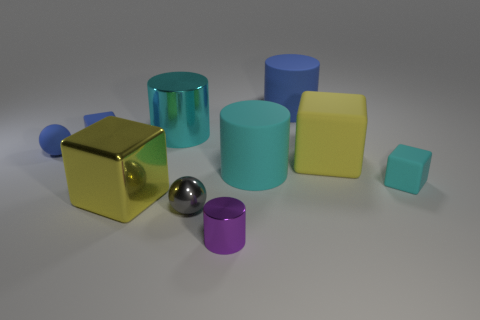Subtract all big yellow metallic cubes. How many cubes are left? 3 Subtract all cyan cylinders. How many cylinders are left? 2 Subtract all cubes. How many objects are left? 6 Subtract 1 spheres. How many spheres are left? 1 Add 4 cubes. How many cubes are left? 8 Add 7 small blue cylinders. How many small blue cylinders exist? 7 Subtract 1 purple cylinders. How many objects are left? 9 Subtract all yellow spheres. Subtract all cyan cylinders. How many spheres are left? 2 Subtract all purple cylinders. How many cyan cubes are left? 1 Subtract all large green shiny objects. Subtract all yellow metal things. How many objects are left? 9 